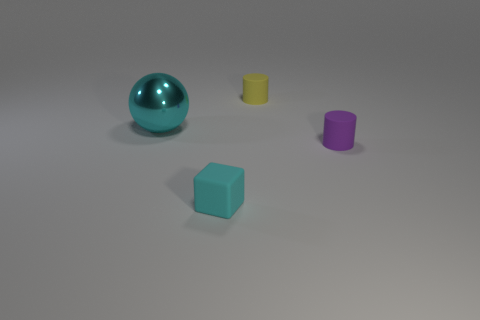Add 2 large gray rubber cubes. How many objects exist? 6 Subtract all balls. How many objects are left? 3 Add 2 small gray metal cylinders. How many small gray metal cylinders exist? 2 Subtract 1 yellow cylinders. How many objects are left? 3 Subtract all small blue blocks. Subtract all rubber cylinders. How many objects are left? 2 Add 1 cylinders. How many cylinders are left? 3 